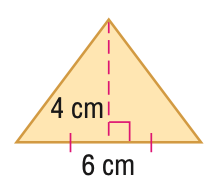Question: Find the area of the figure. Round to the nearest tenth.
Choices:
A. 12
B. 16
C. 18
D. 24
Answer with the letter. Answer: A Question: Find the perimeter or circumference of the figure. Round to the nearest tenth.
Choices:
A. 12
B. 14
C. 16
D. 18
Answer with the letter. Answer: C 